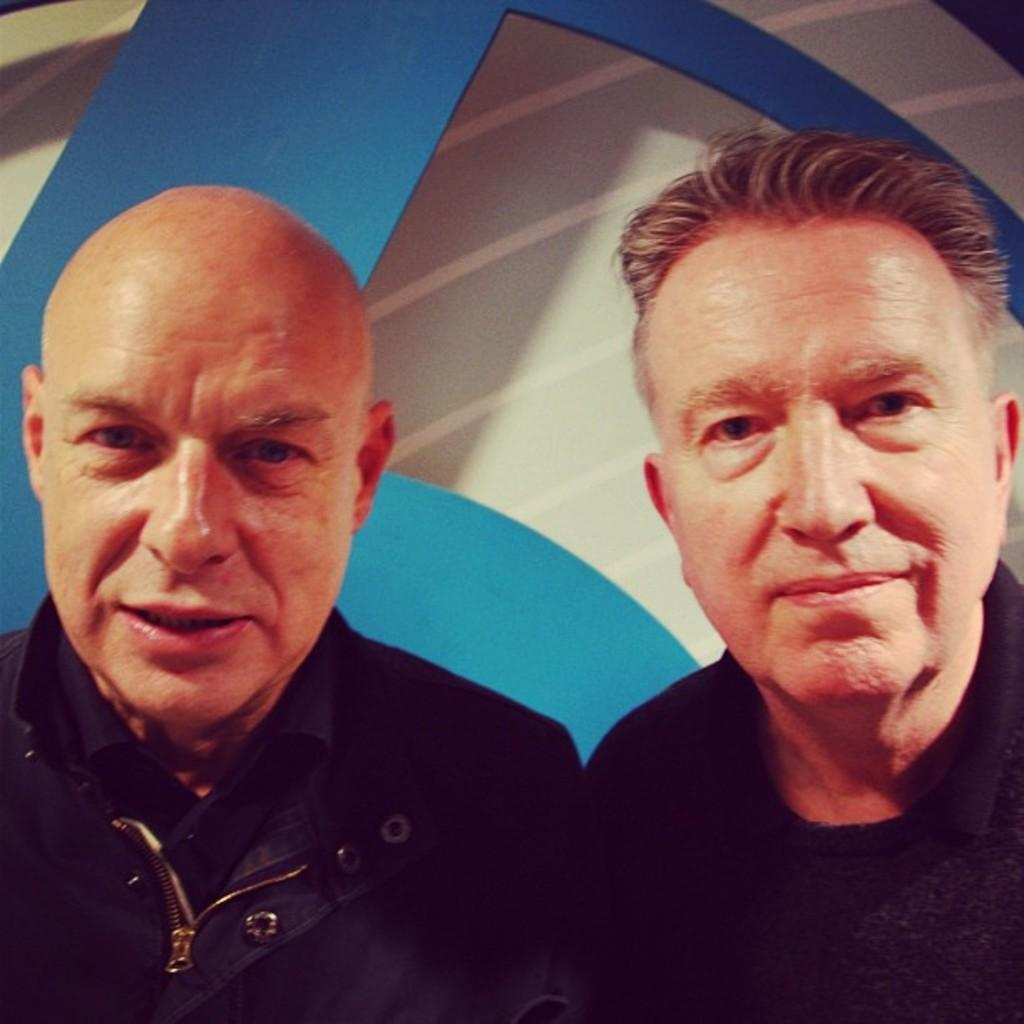How many people are in the image? There are two men in the image. What are the men wearing? The men are wearing clothes. What expression do the men have in the image? The men are smiling. What colors can be seen in the background of the image? The background of the image is blue and white. What type of pie is being served to the men in the image? There is no pie present in the image; it features two men who are smiling. What type of tail can be seen on the men in the image? There are no tails present on the men in the image; they are wearing clothes. 